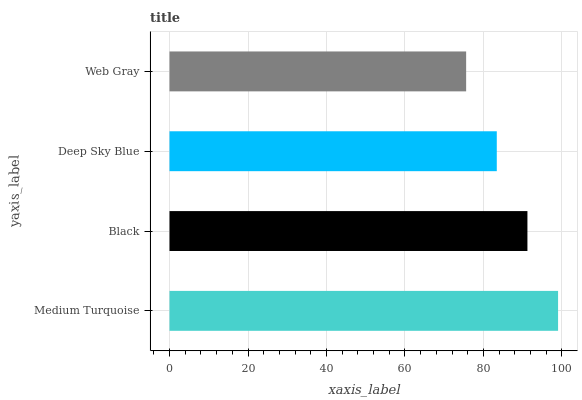Is Web Gray the minimum?
Answer yes or no. Yes. Is Medium Turquoise the maximum?
Answer yes or no. Yes. Is Black the minimum?
Answer yes or no. No. Is Black the maximum?
Answer yes or no. No. Is Medium Turquoise greater than Black?
Answer yes or no. Yes. Is Black less than Medium Turquoise?
Answer yes or no. Yes. Is Black greater than Medium Turquoise?
Answer yes or no. No. Is Medium Turquoise less than Black?
Answer yes or no. No. Is Black the high median?
Answer yes or no. Yes. Is Deep Sky Blue the low median?
Answer yes or no. Yes. Is Web Gray the high median?
Answer yes or no. No. Is Medium Turquoise the low median?
Answer yes or no. No. 